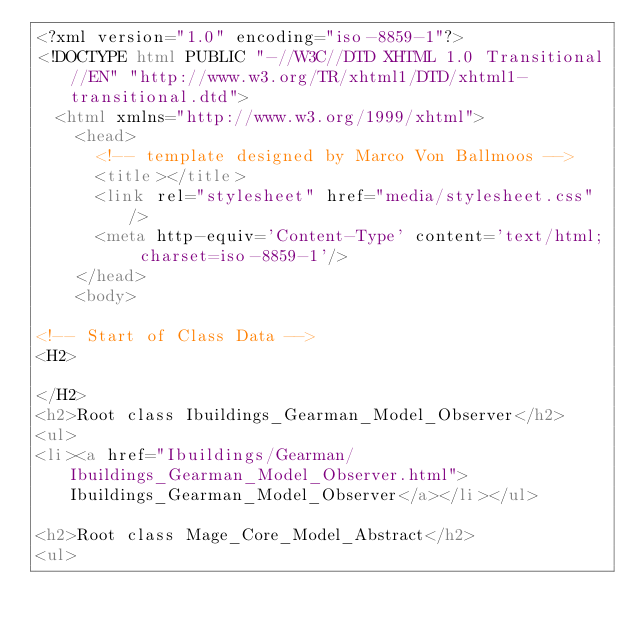<code> <loc_0><loc_0><loc_500><loc_500><_HTML_><?xml version="1.0" encoding="iso-8859-1"?>
<!DOCTYPE html PUBLIC "-//W3C//DTD XHTML 1.0 Transitional//EN" "http://www.w3.org/TR/xhtml1/DTD/xhtml1-transitional.dtd">
  <html xmlns="http://www.w3.org/1999/xhtml">
		<head>
			<!-- template designed by Marco Von Ballmoos -->
			<title></title>
			<link rel="stylesheet" href="media/stylesheet.css" />
			<meta http-equiv='Content-Type' content='text/html; charset=iso-8859-1'/>
		</head>
		<body>
						
<!-- Start of Class Data -->
<H2>
	
</H2>
<h2>Root class Ibuildings_Gearman_Model_Observer</h2>
<ul>
<li><a href="Ibuildings/Gearman/Ibuildings_Gearman_Model_Observer.html">Ibuildings_Gearman_Model_Observer</a></li></ul>

<h2>Root class Mage_Core_Model_Abstract</h2>
<ul></code> 